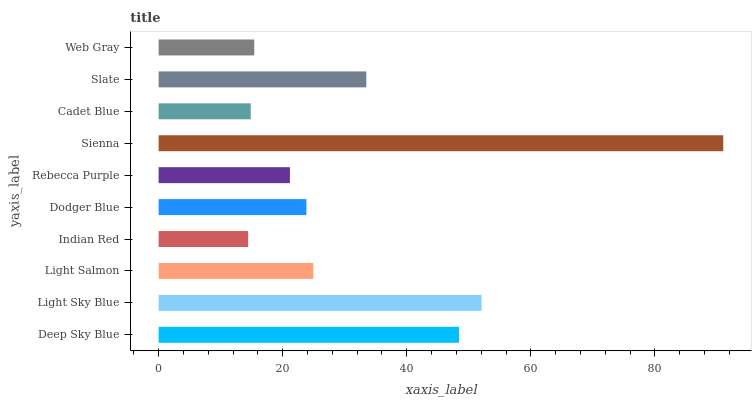Is Indian Red the minimum?
Answer yes or no. Yes. Is Sienna the maximum?
Answer yes or no. Yes. Is Light Sky Blue the minimum?
Answer yes or no. No. Is Light Sky Blue the maximum?
Answer yes or no. No. Is Light Sky Blue greater than Deep Sky Blue?
Answer yes or no. Yes. Is Deep Sky Blue less than Light Sky Blue?
Answer yes or no. Yes. Is Deep Sky Blue greater than Light Sky Blue?
Answer yes or no. No. Is Light Sky Blue less than Deep Sky Blue?
Answer yes or no. No. Is Light Salmon the high median?
Answer yes or no. Yes. Is Dodger Blue the low median?
Answer yes or no. Yes. Is Slate the high median?
Answer yes or no. No. Is Cadet Blue the low median?
Answer yes or no. No. 